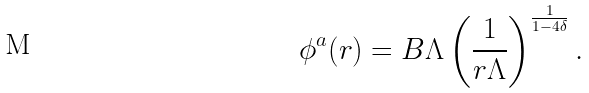<formula> <loc_0><loc_0><loc_500><loc_500>\phi ^ { a } ( r ) = B \Lambda \left ( \frac { 1 } { r \Lambda } \right ) ^ { \frac { 1 } { 1 - 4 \delta } } .</formula> 